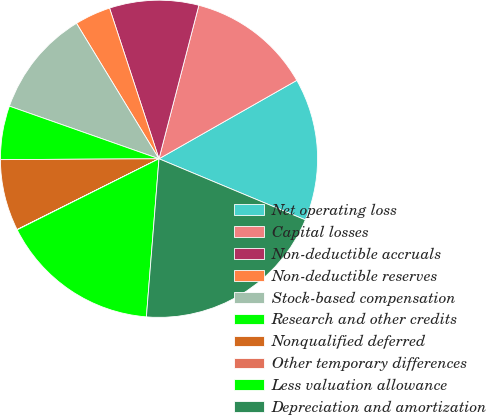Convert chart. <chart><loc_0><loc_0><loc_500><loc_500><pie_chart><fcel>Net operating loss<fcel>Capital losses<fcel>Non-deductible accruals<fcel>Non-deductible reserves<fcel>Stock-based compensation<fcel>Research and other credits<fcel>Nonqualified deferred<fcel>Other temporary differences<fcel>Less valuation allowance<fcel>Depreciation and amortization<nl><fcel>14.53%<fcel>12.72%<fcel>9.09%<fcel>3.66%<fcel>10.91%<fcel>5.47%<fcel>7.28%<fcel>0.03%<fcel>16.34%<fcel>19.97%<nl></chart> 